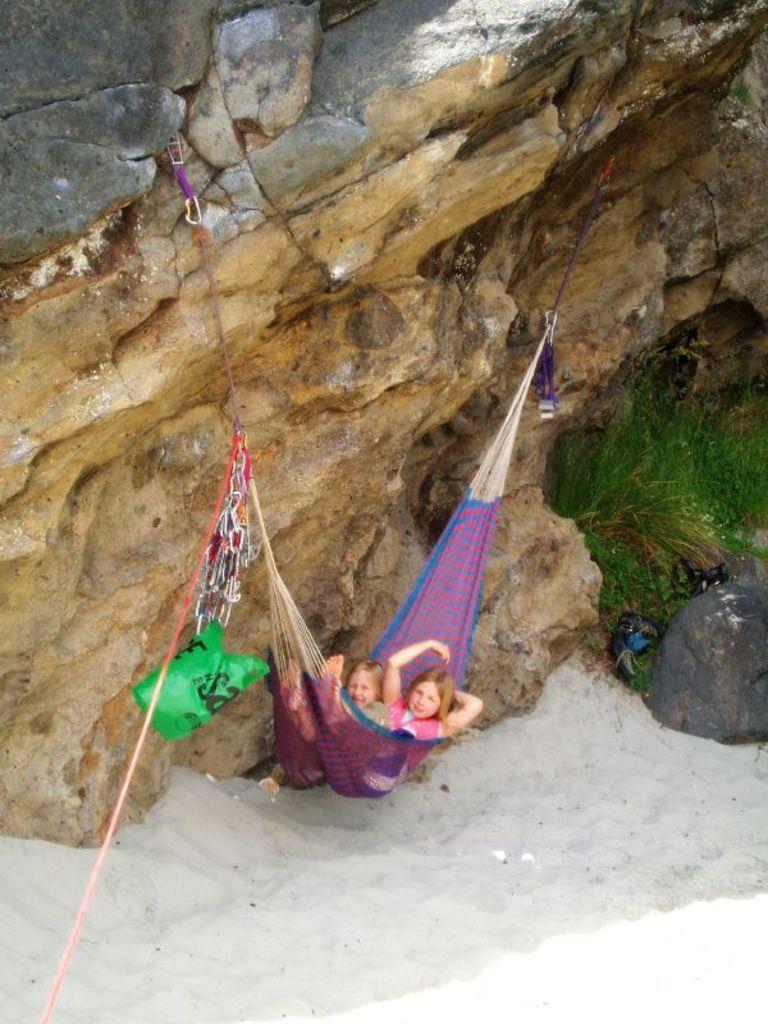In one or two sentences, can you explain what this image depicts? In this image, I can see two persons lying on a hammock, which is tied to a rock. At the bottom of the image, there is sand. On the right side of the image, I can see the grass. 